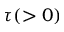<formula> <loc_0><loc_0><loc_500><loc_500>\tau ( > 0 )</formula> 